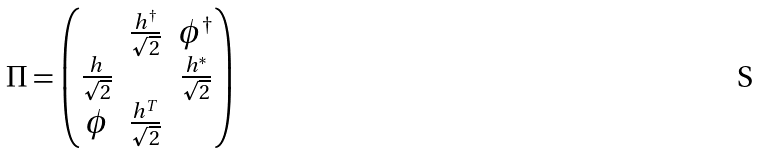Convert formula to latex. <formula><loc_0><loc_0><loc_500><loc_500>\Pi = \begin{pmatrix} \quad & \frac { h ^ { \dagger } } { \sqrt { 2 } } & \phi ^ { \dagger } \\ \frac { h } { \sqrt { 2 } } & \quad & \frac { h ^ { * } } { \sqrt { 2 } } \\ \phi & \frac { h ^ { T } } { \sqrt { 2 } } & \quad \end{pmatrix}</formula> 